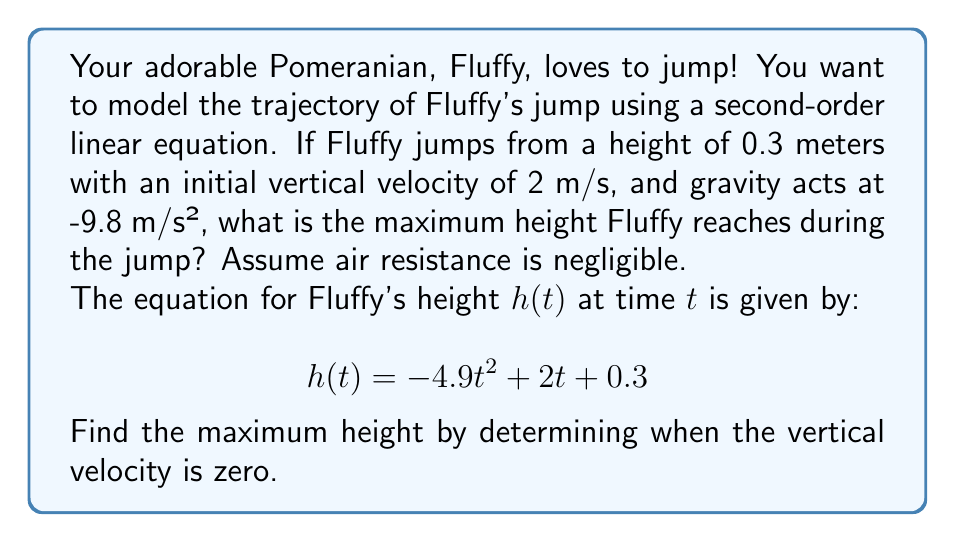Help me with this question. Let's approach this step-by-step:

1) The given equation for Fluffy's height is:
   $$h(t) = -4.9t^2 + 2t + 0.3$$

2) To find the maximum height, we need to find when the vertical velocity is zero. The vertical velocity is the derivative of the height function:
   $$v(t) = h'(t) = -9.8t + 2$$

3) Set the velocity to zero and solve for t:
   $$-9.8t + 2 = 0$$
   $$-9.8t = -2$$
   $$t = \frac{2}{9.8} = 0.204\text{ seconds}$$

4) Now that we know the time when Fluffy reaches the maximum height, we can plug this back into the original height equation:

   $$h(0.204) = -4.9(0.204)^2 + 2(0.204) + 0.3$$

5) Let's calculate this step by step:
   $$h(0.204) = -4.9(0.041616) + 0.408 + 0.3$$
   $$h(0.204) = -0.203918 + 0.408 + 0.3$$
   $$h(0.204) = 0.504082\text{ meters}$$

6) Rounding to two decimal places for practicality:
   $$h(0.204) \approx 0.50\text{ meters}$$

Therefore, the maximum height Fluffy reaches during the jump is approximately 0.50 meters.
Answer: The maximum height Fluffy reaches during the jump is approximately 0.50 meters. 